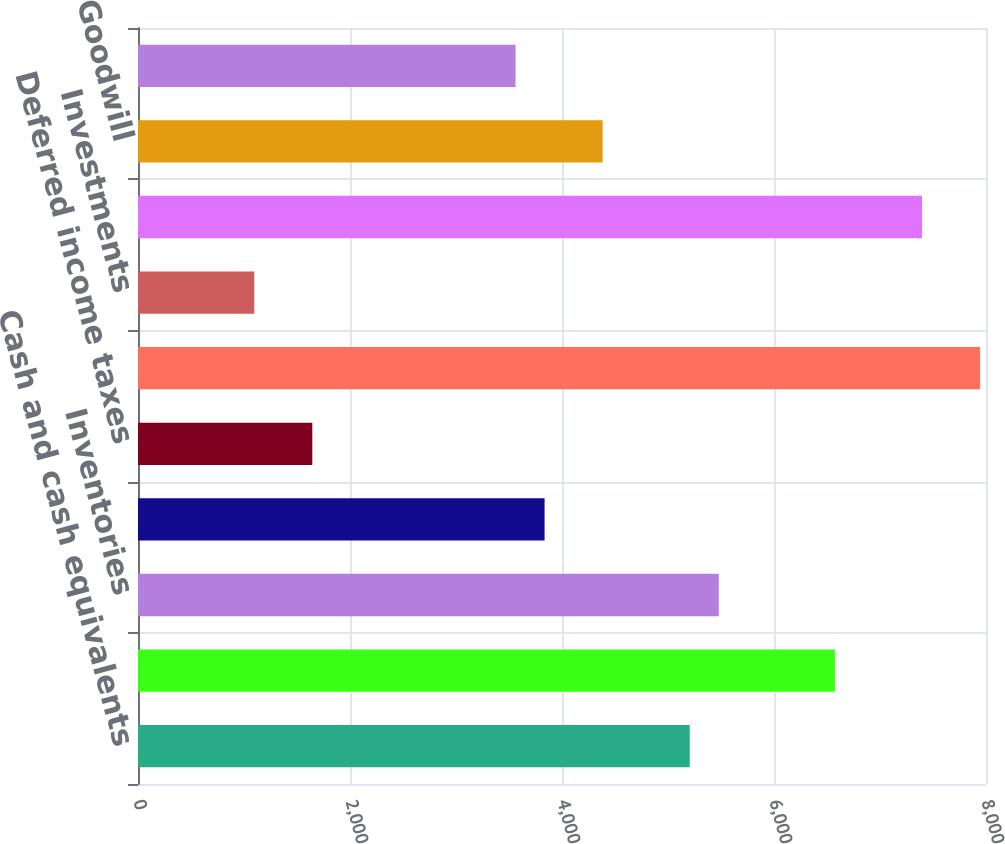Convert chart to OTSL. <chart><loc_0><loc_0><loc_500><loc_500><bar_chart><fcel>Cash and cash equivalents<fcel>Trade receivables net of<fcel>Inventories<fcel>Prepaid and other current<fcel>Deferred income taxes<fcel>Total current assets<fcel>Investments<fcel>Property plant and equipment<fcel>Goodwill<fcel>Other assets<nl><fcel>5205.19<fcel>6574.74<fcel>5479.1<fcel>3835.64<fcel>1644.36<fcel>7944.29<fcel>1096.54<fcel>7396.47<fcel>4383.46<fcel>3561.73<nl></chart> 